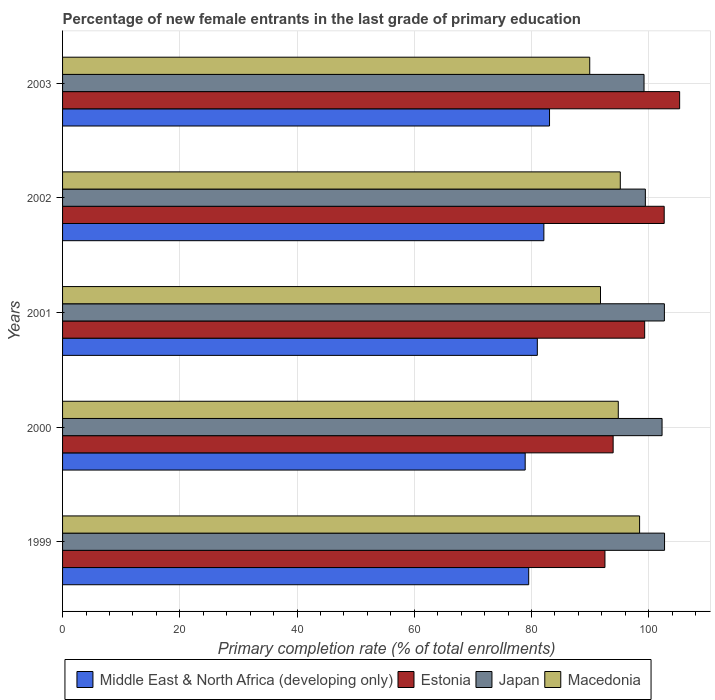How many groups of bars are there?
Your response must be concise. 5. How many bars are there on the 1st tick from the top?
Your answer should be very brief. 4. What is the label of the 1st group of bars from the top?
Provide a succinct answer. 2003. What is the percentage of new female entrants in Estonia in 2000?
Offer a very short reply. 93.93. Across all years, what is the maximum percentage of new female entrants in Macedonia?
Provide a short and direct response. 98.44. Across all years, what is the minimum percentage of new female entrants in Middle East & North Africa (developing only)?
Your answer should be compact. 78.92. What is the total percentage of new female entrants in Japan in the graph?
Offer a terse response. 506.26. What is the difference between the percentage of new female entrants in Japan in 2002 and that in 2003?
Keep it short and to the point. 0.23. What is the difference between the percentage of new female entrants in Macedonia in 2001 and the percentage of new female entrants in Estonia in 1999?
Provide a short and direct response. -0.76. What is the average percentage of new female entrants in Japan per year?
Provide a succinct answer. 101.25. In the year 1999, what is the difference between the percentage of new female entrants in Macedonia and percentage of new female entrants in Middle East & North Africa (developing only)?
Keep it short and to the point. 18.92. In how many years, is the percentage of new female entrants in Japan greater than 76 %?
Your response must be concise. 5. What is the ratio of the percentage of new female entrants in Japan in 2001 to that in 2002?
Your answer should be compact. 1.03. Is the difference between the percentage of new female entrants in Macedonia in 2000 and 2001 greater than the difference between the percentage of new female entrants in Middle East & North Africa (developing only) in 2000 and 2001?
Keep it short and to the point. Yes. What is the difference between the highest and the second highest percentage of new female entrants in Japan?
Your answer should be very brief. 0.03. What is the difference between the highest and the lowest percentage of new female entrants in Macedonia?
Ensure brevity in your answer.  8.51. In how many years, is the percentage of new female entrants in Japan greater than the average percentage of new female entrants in Japan taken over all years?
Provide a succinct answer. 3. Is the sum of the percentage of new female entrants in Estonia in 1999 and 2000 greater than the maximum percentage of new female entrants in Middle East & North Africa (developing only) across all years?
Keep it short and to the point. Yes. Is it the case that in every year, the sum of the percentage of new female entrants in Estonia and percentage of new female entrants in Middle East & North Africa (developing only) is greater than the sum of percentage of new female entrants in Japan and percentage of new female entrants in Macedonia?
Ensure brevity in your answer.  Yes. What does the 4th bar from the top in 2003 represents?
Give a very brief answer. Middle East & North Africa (developing only). What does the 4th bar from the bottom in 2003 represents?
Keep it short and to the point. Macedonia. Is it the case that in every year, the sum of the percentage of new female entrants in Macedonia and percentage of new female entrants in Middle East & North Africa (developing only) is greater than the percentage of new female entrants in Japan?
Your answer should be very brief. Yes. Are all the bars in the graph horizontal?
Your answer should be very brief. Yes. What is the difference between two consecutive major ticks on the X-axis?
Ensure brevity in your answer.  20. Where does the legend appear in the graph?
Your answer should be compact. Bottom center. What is the title of the graph?
Offer a terse response. Percentage of new female entrants in the last grade of primary education. Does "Vietnam" appear as one of the legend labels in the graph?
Offer a terse response. No. What is the label or title of the X-axis?
Ensure brevity in your answer.  Primary completion rate (% of total enrollments). What is the Primary completion rate (% of total enrollments) in Middle East & North Africa (developing only) in 1999?
Offer a very short reply. 79.52. What is the Primary completion rate (% of total enrollments) in Estonia in 1999?
Keep it short and to the point. 92.53. What is the Primary completion rate (% of total enrollments) in Japan in 1999?
Offer a terse response. 102.7. What is the Primary completion rate (% of total enrollments) of Macedonia in 1999?
Make the answer very short. 98.44. What is the Primary completion rate (% of total enrollments) of Middle East & North Africa (developing only) in 2000?
Make the answer very short. 78.92. What is the Primary completion rate (% of total enrollments) of Estonia in 2000?
Provide a succinct answer. 93.93. What is the Primary completion rate (% of total enrollments) of Japan in 2000?
Your answer should be compact. 102.27. What is the Primary completion rate (% of total enrollments) of Macedonia in 2000?
Provide a succinct answer. 94.8. What is the Primary completion rate (% of total enrollments) of Middle East & North Africa (developing only) in 2001?
Your response must be concise. 80.99. What is the Primary completion rate (% of total enrollments) in Estonia in 2001?
Provide a succinct answer. 99.31. What is the Primary completion rate (% of total enrollments) of Japan in 2001?
Your answer should be compact. 102.67. What is the Primary completion rate (% of total enrollments) in Macedonia in 2001?
Ensure brevity in your answer.  91.77. What is the Primary completion rate (% of total enrollments) of Middle East & North Africa (developing only) in 2002?
Provide a short and direct response. 82.11. What is the Primary completion rate (% of total enrollments) in Estonia in 2002?
Ensure brevity in your answer.  102.64. What is the Primary completion rate (% of total enrollments) in Japan in 2002?
Keep it short and to the point. 99.42. What is the Primary completion rate (% of total enrollments) of Macedonia in 2002?
Your response must be concise. 95.15. What is the Primary completion rate (% of total enrollments) in Middle East & North Africa (developing only) in 2003?
Your response must be concise. 83.07. What is the Primary completion rate (% of total enrollments) of Estonia in 2003?
Offer a terse response. 105.27. What is the Primary completion rate (% of total enrollments) in Japan in 2003?
Make the answer very short. 99.2. What is the Primary completion rate (% of total enrollments) in Macedonia in 2003?
Your response must be concise. 89.93. Across all years, what is the maximum Primary completion rate (% of total enrollments) of Middle East & North Africa (developing only)?
Give a very brief answer. 83.07. Across all years, what is the maximum Primary completion rate (% of total enrollments) in Estonia?
Provide a short and direct response. 105.27. Across all years, what is the maximum Primary completion rate (% of total enrollments) in Japan?
Keep it short and to the point. 102.7. Across all years, what is the maximum Primary completion rate (% of total enrollments) in Macedonia?
Keep it short and to the point. 98.44. Across all years, what is the minimum Primary completion rate (% of total enrollments) in Middle East & North Africa (developing only)?
Offer a very short reply. 78.92. Across all years, what is the minimum Primary completion rate (% of total enrollments) in Estonia?
Ensure brevity in your answer.  92.53. Across all years, what is the minimum Primary completion rate (% of total enrollments) in Japan?
Keep it short and to the point. 99.2. Across all years, what is the minimum Primary completion rate (% of total enrollments) in Macedonia?
Provide a short and direct response. 89.93. What is the total Primary completion rate (% of total enrollments) in Middle East & North Africa (developing only) in the graph?
Offer a very short reply. 404.62. What is the total Primary completion rate (% of total enrollments) in Estonia in the graph?
Provide a short and direct response. 493.67. What is the total Primary completion rate (% of total enrollments) in Japan in the graph?
Offer a very short reply. 506.26. What is the total Primary completion rate (% of total enrollments) of Macedonia in the graph?
Your answer should be very brief. 470.09. What is the difference between the Primary completion rate (% of total enrollments) in Middle East & North Africa (developing only) in 1999 and that in 2000?
Provide a short and direct response. 0.6. What is the difference between the Primary completion rate (% of total enrollments) of Estonia in 1999 and that in 2000?
Offer a terse response. -1.4. What is the difference between the Primary completion rate (% of total enrollments) in Japan in 1999 and that in 2000?
Give a very brief answer. 0.42. What is the difference between the Primary completion rate (% of total enrollments) in Macedonia in 1999 and that in 2000?
Your response must be concise. 3.64. What is the difference between the Primary completion rate (% of total enrollments) of Middle East & North Africa (developing only) in 1999 and that in 2001?
Your answer should be very brief. -1.47. What is the difference between the Primary completion rate (% of total enrollments) in Estonia in 1999 and that in 2001?
Offer a very short reply. -6.78. What is the difference between the Primary completion rate (% of total enrollments) of Japan in 1999 and that in 2001?
Your answer should be very brief. 0.03. What is the difference between the Primary completion rate (% of total enrollments) of Macedonia in 1999 and that in 2001?
Offer a very short reply. 6.67. What is the difference between the Primary completion rate (% of total enrollments) in Middle East & North Africa (developing only) in 1999 and that in 2002?
Your answer should be compact. -2.59. What is the difference between the Primary completion rate (% of total enrollments) in Estonia in 1999 and that in 2002?
Keep it short and to the point. -10.11. What is the difference between the Primary completion rate (% of total enrollments) of Japan in 1999 and that in 2002?
Make the answer very short. 3.27. What is the difference between the Primary completion rate (% of total enrollments) of Macedonia in 1999 and that in 2002?
Offer a terse response. 3.29. What is the difference between the Primary completion rate (% of total enrollments) in Middle East & North Africa (developing only) in 1999 and that in 2003?
Your answer should be very brief. -3.55. What is the difference between the Primary completion rate (% of total enrollments) of Estonia in 1999 and that in 2003?
Provide a succinct answer. -12.74. What is the difference between the Primary completion rate (% of total enrollments) in Japan in 1999 and that in 2003?
Ensure brevity in your answer.  3.5. What is the difference between the Primary completion rate (% of total enrollments) of Macedonia in 1999 and that in 2003?
Your answer should be compact. 8.51. What is the difference between the Primary completion rate (% of total enrollments) in Middle East & North Africa (developing only) in 2000 and that in 2001?
Your response must be concise. -2.07. What is the difference between the Primary completion rate (% of total enrollments) in Estonia in 2000 and that in 2001?
Give a very brief answer. -5.38. What is the difference between the Primary completion rate (% of total enrollments) of Japan in 2000 and that in 2001?
Give a very brief answer. -0.4. What is the difference between the Primary completion rate (% of total enrollments) in Macedonia in 2000 and that in 2001?
Your response must be concise. 3.03. What is the difference between the Primary completion rate (% of total enrollments) in Middle East & North Africa (developing only) in 2000 and that in 2002?
Provide a succinct answer. -3.19. What is the difference between the Primary completion rate (% of total enrollments) of Estonia in 2000 and that in 2002?
Your response must be concise. -8.71. What is the difference between the Primary completion rate (% of total enrollments) in Japan in 2000 and that in 2002?
Make the answer very short. 2.85. What is the difference between the Primary completion rate (% of total enrollments) of Macedonia in 2000 and that in 2002?
Your answer should be very brief. -0.34. What is the difference between the Primary completion rate (% of total enrollments) in Middle East & North Africa (developing only) in 2000 and that in 2003?
Your response must be concise. -4.15. What is the difference between the Primary completion rate (% of total enrollments) of Estonia in 2000 and that in 2003?
Provide a short and direct response. -11.34. What is the difference between the Primary completion rate (% of total enrollments) of Japan in 2000 and that in 2003?
Provide a succinct answer. 3.08. What is the difference between the Primary completion rate (% of total enrollments) of Macedonia in 2000 and that in 2003?
Offer a terse response. 4.87. What is the difference between the Primary completion rate (% of total enrollments) in Middle East & North Africa (developing only) in 2001 and that in 2002?
Your answer should be very brief. -1.12. What is the difference between the Primary completion rate (% of total enrollments) of Estonia in 2001 and that in 2002?
Keep it short and to the point. -3.33. What is the difference between the Primary completion rate (% of total enrollments) of Japan in 2001 and that in 2002?
Offer a terse response. 3.25. What is the difference between the Primary completion rate (% of total enrollments) of Macedonia in 2001 and that in 2002?
Your answer should be compact. -3.38. What is the difference between the Primary completion rate (% of total enrollments) in Middle East & North Africa (developing only) in 2001 and that in 2003?
Keep it short and to the point. -2.08. What is the difference between the Primary completion rate (% of total enrollments) in Estonia in 2001 and that in 2003?
Your response must be concise. -5.96. What is the difference between the Primary completion rate (% of total enrollments) of Japan in 2001 and that in 2003?
Make the answer very short. 3.47. What is the difference between the Primary completion rate (% of total enrollments) of Macedonia in 2001 and that in 2003?
Offer a very short reply. 1.83. What is the difference between the Primary completion rate (% of total enrollments) in Middle East & North Africa (developing only) in 2002 and that in 2003?
Offer a terse response. -0.96. What is the difference between the Primary completion rate (% of total enrollments) in Estonia in 2002 and that in 2003?
Provide a short and direct response. -2.63. What is the difference between the Primary completion rate (% of total enrollments) of Japan in 2002 and that in 2003?
Your response must be concise. 0.23. What is the difference between the Primary completion rate (% of total enrollments) in Macedonia in 2002 and that in 2003?
Offer a terse response. 5.21. What is the difference between the Primary completion rate (% of total enrollments) in Middle East & North Africa (developing only) in 1999 and the Primary completion rate (% of total enrollments) in Estonia in 2000?
Ensure brevity in your answer.  -14.4. What is the difference between the Primary completion rate (% of total enrollments) of Middle East & North Africa (developing only) in 1999 and the Primary completion rate (% of total enrollments) of Japan in 2000?
Ensure brevity in your answer.  -22.75. What is the difference between the Primary completion rate (% of total enrollments) of Middle East & North Africa (developing only) in 1999 and the Primary completion rate (% of total enrollments) of Macedonia in 2000?
Make the answer very short. -15.28. What is the difference between the Primary completion rate (% of total enrollments) in Estonia in 1999 and the Primary completion rate (% of total enrollments) in Japan in 2000?
Your answer should be compact. -9.74. What is the difference between the Primary completion rate (% of total enrollments) of Estonia in 1999 and the Primary completion rate (% of total enrollments) of Macedonia in 2000?
Offer a terse response. -2.27. What is the difference between the Primary completion rate (% of total enrollments) in Japan in 1999 and the Primary completion rate (% of total enrollments) in Macedonia in 2000?
Offer a terse response. 7.89. What is the difference between the Primary completion rate (% of total enrollments) in Middle East & North Africa (developing only) in 1999 and the Primary completion rate (% of total enrollments) in Estonia in 2001?
Provide a short and direct response. -19.78. What is the difference between the Primary completion rate (% of total enrollments) of Middle East & North Africa (developing only) in 1999 and the Primary completion rate (% of total enrollments) of Japan in 2001?
Make the answer very short. -23.15. What is the difference between the Primary completion rate (% of total enrollments) of Middle East & North Africa (developing only) in 1999 and the Primary completion rate (% of total enrollments) of Macedonia in 2001?
Give a very brief answer. -12.25. What is the difference between the Primary completion rate (% of total enrollments) in Estonia in 1999 and the Primary completion rate (% of total enrollments) in Japan in 2001?
Keep it short and to the point. -10.14. What is the difference between the Primary completion rate (% of total enrollments) of Estonia in 1999 and the Primary completion rate (% of total enrollments) of Macedonia in 2001?
Keep it short and to the point. 0.76. What is the difference between the Primary completion rate (% of total enrollments) of Japan in 1999 and the Primary completion rate (% of total enrollments) of Macedonia in 2001?
Offer a terse response. 10.93. What is the difference between the Primary completion rate (% of total enrollments) in Middle East & North Africa (developing only) in 1999 and the Primary completion rate (% of total enrollments) in Estonia in 2002?
Provide a short and direct response. -23.12. What is the difference between the Primary completion rate (% of total enrollments) in Middle East & North Africa (developing only) in 1999 and the Primary completion rate (% of total enrollments) in Japan in 2002?
Keep it short and to the point. -19.9. What is the difference between the Primary completion rate (% of total enrollments) in Middle East & North Africa (developing only) in 1999 and the Primary completion rate (% of total enrollments) in Macedonia in 2002?
Ensure brevity in your answer.  -15.63. What is the difference between the Primary completion rate (% of total enrollments) of Estonia in 1999 and the Primary completion rate (% of total enrollments) of Japan in 2002?
Ensure brevity in your answer.  -6.89. What is the difference between the Primary completion rate (% of total enrollments) in Estonia in 1999 and the Primary completion rate (% of total enrollments) in Macedonia in 2002?
Provide a short and direct response. -2.62. What is the difference between the Primary completion rate (% of total enrollments) of Japan in 1999 and the Primary completion rate (% of total enrollments) of Macedonia in 2002?
Provide a succinct answer. 7.55. What is the difference between the Primary completion rate (% of total enrollments) in Middle East & North Africa (developing only) in 1999 and the Primary completion rate (% of total enrollments) in Estonia in 2003?
Give a very brief answer. -25.75. What is the difference between the Primary completion rate (% of total enrollments) of Middle East & North Africa (developing only) in 1999 and the Primary completion rate (% of total enrollments) of Japan in 2003?
Ensure brevity in your answer.  -19.68. What is the difference between the Primary completion rate (% of total enrollments) in Middle East & North Africa (developing only) in 1999 and the Primary completion rate (% of total enrollments) in Macedonia in 2003?
Keep it short and to the point. -10.41. What is the difference between the Primary completion rate (% of total enrollments) in Estonia in 1999 and the Primary completion rate (% of total enrollments) in Japan in 2003?
Provide a succinct answer. -6.67. What is the difference between the Primary completion rate (% of total enrollments) in Estonia in 1999 and the Primary completion rate (% of total enrollments) in Macedonia in 2003?
Your answer should be very brief. 2.6. What is the difference between the Primary completion rate (% of total enrollments) in Japan in 1999 and the Primary completion rate (% of total enrollments) in Macedonia in 2003?
Offer a very short reply. 12.76. What is the difference between the Primary completion rate (% of total enrollments) of Middle East & North Africa (developing only) in 2000 and the Primary completion rate (% of total enrollments) of Estonia in 2001?
Make the answer very short. -20.38. What is the difference between the Primary completion rate (% of total enrollments) of Middle East & North Africa (developing only) in 2000 and the Primary completion rate (% of total enrollments) of Japan in 2001?
Your answer should be compact. -23.75. What is the difference between the Primary completion rate (% of total enrollments) of Middle East & North Africa (developing only) in 2000 and the Primary completion rate (% of total enrollments) of Macedonia in 2001?
Provide a short and direct response. -12.85. What is the difference between the Primary completion rate (% of total enrollments) in Estonia in 2000 and the Primary completion rate (% of total enrollments) in Japan in 2001?
Offer a terse response. -8.74. What is the difference between the Primary completion rate (% of total enrollments) of Estonia in 2000 and the Primary completion rate (% of total enrollments) of Macedonia in 2001?
Your response must be concise. 2.16. What is the difference between the Primary completion rate (% of total enrollments) of Japan in 2000 and the Primary completion rate (% of total enrollments) of Macedonia in 2001?
Your response must be concise. 10.5. What is the difference between the Primary completion rate (% of total enrollments) of Middle East & North Africa (developing only) in 2000 and the Primary completion rate (% of total enrollments) of Estonia in 2002?
Your response must be concise. -23.72. What is the difference between the Primary completion rate (% of total enrollments) of Middle East & North Africa (developing only) in 2000 and the Primary completion rate (% of total enrollments) of Japan in 2002?
Offer a very short reply. -20.5. What is the difference between the Primary completion rate (% of total enrollments) in Middle East & North Africa (developing only) in 2000 and the Primary completion rate (% of total enrollments) in Macedonia in 2002?
Provide a short and direct response. -16.23. What is the difference between the Primary completion rate (% of total enrollments) in Estonia in 2000 and the Primary completion rate (% of total enrollments) in Japan in 2002?
Your answer should be very brief. -5.5. What is the difference between the Primary completion rate (% of total enrollments) of Estonia in 2000 and the Primary completion rate (% of total enrollments) of Macedonia in 2002?
Give a very brief answer. -1.22. What is the difference between the Primary completion rate (% of total enrollments) in Japan in 2000 and the Primary completion rate (% of total enrollments) in Macedonia in 2002?
Keep it short and to the point. 7.13. What is the difference between the Primary completion rate (% of total enrollments) in Middle East & North Africa (developing only) in 2000 and the Primary completion rate (% of total enrollments) in Estonia in 2003?
Your answer should be compact. -26.35. What is the difference between the Primary completion rate (% of total enrollments) in Middle East & North Africa (developing only) in 2000 and the Primary completion rate (% of total enrollments) in Japan in 2003?
Provide a short and direct response. -20.28. What is the difference between the Primary completion rate (% of total enrollments) of Middle East & North Africa (developing only) in 2000 and the Primary completion rate (% of total enrollments) of Macedonia in 2003?
Your answer should be compact. -11.01. What is the difference between the Primary completion rate (% of total enrollments) in Estonia in 2000 and the Primary completion rate (% of total enrollments) in Japan in 2003?
Provide a succinct answer. -5.27. What is the difference between the Primary completion rate (% of total enrollments) in Estonia in 2000 and the Primary completion rate (% of total enrollments) in Macedonia in 2003?
Your response must be concise. 3.99. What is the difference between the Primary completion rate (% of total enrollments) in Japan in 2000 and the Primary completion rate (% of total enrollments) in Macedonia in 2003?
Make the answer very short. 12.34. What is the difference between the Primary completion rate (% of total enrollments) in Middle East & North Africa (developing only) in 2001 and the Primary completion rate (% of total enrollments) in Estonia in 2002?
Give a very brief answer. -21.65. What is the difference between the Primary completion rate (% of total enrollments) in Middle East & North Africa (developing only) in 2001 and the Primary completion rate (% of total enrollments) in Japan in 2002?
Give a very brief answer. -18.43. What is the difference between the Primary completion rate (% of total enrollments) in Middle East & North Africa (developing only) in 2001 and the Primary completion rate (% of total enrollments) in Macedonia in 2002?
Ensure brevity in your answer.  -14.15. What is the difference between the Primary completion rate (% of total enrollments) of Estonia in 2001 and the Primary completion rate (% of total enrollments) of Japan in 2002?
Your answer should be very brief. -0.12. What is the difference between the Primary completion rate (% of total enrollments) in Estonia in 2001 and the Primary completion rate (% of total enrollments) in Macedonia in 2002?
Your answer should be very brief. 4.16. What is the difference between the Primary completion rate (% of total enrollments) in Japan in 2001 and the Primary completion rate (% of total enrollments) in Macedonia in 2002?
Offer a terse response. 7.52. What is the difference between the Primary completion rate (% of total enrollments) in Middle East & North Africa (developing only) in 2001 and the Primary completion rate (% of total enrollments) in Estonia in 2003?
Offer a terse response. -24.28. What is the difference between the Primary completion rate (% of total enrollments) of Middle East & North Africa (developing only) in 2001 and the Primary completion rate (% of total enrollments) of Japan in 2003?
Your answer should be very brief. -18.2. What is the difference between the Primary completion rate (% of total enrollments) of Middle East & North Africa (developing only) in 2001 and the Primary completion rate (% of total enrollments) of Macedonia in 2003?
Your answer should be compact. -8.94. What is the difference between the Primary completion rate (% of total enrollments) of Estonia in 2001 and the Primary completion rate (% of total enrollments) of Japan in 2003?
Provide a short and direct response. 0.11. What is the difference between the Primary completion rate (% of total enrollments) in Estonia in 2001 and the Primary completion rate (% of total enrollments) in Macedonia in 2003?
Keep it short and to the point. 9.37. What is the difference between the Primary completion rate (% of total enrollments) of Japan in 2001 and the Primary completion rate (% of total enrollments) of Macedonia in 2003?
Provide a succinct answer. 12.74. What is the difference between the Primary completion rate (% of total enrollments) of Middle East & North Africa (developing only) in 2002 and the Primary completion rate (% of total enrollments) of Estonia in 2003?
Ensure brevity in your answer.  -23.16. What is the difference between the Primary completion rate (% of total enrollments) of Middle East & North Africa (developing only) in 2002 and the Primary completion rate (% of total enrollments) of Japan in 2003?
Your response must be concise. -17.09. What is the difference between the Primary completion rate (% of total enrollments) in Middle East & North Africa (developing only) in 2002 and the Primary completion rate (% of total enrollments) in Macedonia in 2003?
Offer a terse response. -7.82. What is the difference between the Primary completion rate (% of total enrollments) of Estonia in 2002 and the Primary completion rate (% of total enrollments) of Japan in 2003?
Your answer should be very brief. 3.44. What is the difference between the Primary completion rate (% of total enrollments) of Estonia in 2002 and the Primary completion rate (% of total enrollments) of Macedonia in 2003?
Offer a very short reply. 12.7. What is the difference between the Primary completion rate (% of total enrollments) in Japan in 2002 and the Primary completion rate (% of total enrollments) in Macedonia in 2003?
Keep it short and to the point. 9.49. What is the average Primary completion rate (% of total enrollments) of Middle East & North Africa (developing only) per year?
Keep it short and to the point. 80.92. What is the average Primary completion rate (% of total enrollments) of Estonia per year?
Offer a very short reply. 98.73. What is the average Primary completion rate (% of total enrollments) of Japan per year?
Keep it short and to the point. 101.25. What is the average Primary completion rate (% of total enrollments) in Macedonia per year?
Provide a succinct answer. 94.02. In the year 1999, what is the difference between the Primary completion rate (% of total enrollments) in Middle East & North Africa (developing only) and Primary completion rate (% of total enrollments) in Estonia?
Provide a succinct answer. -13.01. In the year 1999, what is the difference between the Primary completion rate (% of total enrollments) of Middle East & North Africa (developing only) and Primary completion rate (% of total enrollments) of Japan?
Make the answer very short. -23.17. In the year 1999, what is the difference between the Primary completion rate (% of total enrollments) in Middle East & North Africa (developing only) and Primary completion rate (% of total enrollments) in Macedonia?
Make the answer very short. -18.92. In the year 1999, what is the difference between the Primary completion rate (% of total enrollments) in Estonia and Primary completion rate (% of total enrollments) in Japan?
Keep it short and to the point. -10.17. In the year 1999, what is the difference between the Primary completion rate (% of total enrollments) of Estonia and Primary completion rate (% of total enrollments) of Macedonia?
Your answer should be very brief. -5.91. In the year 1999, what is the difference between the Primary completion rate (% of total enrollments) of Japan and Primary completion rate (% of total enrollments) of Macedonia?
Provide a succinct answer. 4.26. In the year 2000, what is the difference between the Primary completion rate (% of total enrollments) of Middle East & North Africa (developing only) and Primary completion rate (% of total enrollments) of Estonia?
Make the answer very short. -15.01. In the year 2000, what is the difference between the Primary completion rate (% of total enrollments) of Middle East & North Africa (developing only) and Primary completion rate (% of total enrollments) of Japan?
Provide a short and direct response. -23.35. In the year 2000, what is the difference between the Primary completion rate (% of total enrollments) in Middle East & North Africa (developing only) and Primary completion rate (% of total enrollments) in Macedonia?
Your answer should be compact. -15.88. In the year 2000, what is the difference between the Primary completion rate (% of total enrollments) of Estonia and Primary completion rate (% of total enrollments) of Japan?
Your answer should be very brief. -8.35. In the year 2000, what is the difference between the Primary completion rate (% of total enrollments) of Estonia and Primary completion rate (% of total enrollments) of Macedonia?
Your answer should be compact. -0.88. In the year 2000, what is the difference between the Primary completion rate (% of total enrollments) of Japan and Primary completion rate (% of total enrollments) of Macedonia?
Give a very brief answer. 7.47. In the year 2001, what is the difference between the Primary completion rate (% of total enrollments) of Middle East & North Africa (developing only) and Primary completion rate (% of total enrollments) of Estonia?
Give a very brief answer. -18.31. In the year 2001, what is the difference between the Primary completion rate (% of total enrollments) in Middle East & North Africa (developing only) and Primary completion rate (% of total enrollments) in Japan?
Make the answer very short. -21.68. In the year 2001, what is the difference between the Primary completion rate (% of total enrollments) of Middle East & North Africa (developing only) and Primary completion rate (% of total enrollments) of Macedonia?
Keep it short and to the point. -10.78. In the year 2001, what is the difference between the Primary completion rate (% of total enrollments) in Estonia and Primary completion rate (% of total enrollments) in Japan?
Offer a terse response. -3.36. In the year 2001, what is the difference between the Primary completion rate (% of total enrollments) of Estonia and Primary completion rate (% of total enrollments) of Macedonia?
Offer a terse response. 7.54. In the year 2001, what is the difference between the Primary completion rate (% of total enrollments) of Japan and Primary completion rate (% of total enrollments) of Macedonia?
Offer a very short reply. 10.9. In the year 2002, what is the difference between the Primary completion rate (% of total enrollments) of Middle East & North Africa (developing only) and Primary completion rate (% of total enrollments) of Estonia?
Your answer should be compact. -20.53. In the year 2002, what is the difference between the Primary completion rate (% of total enrollments) in Middle East & North Africa (developing only) and Primary completion rate (% of total enrollments) in Japan?
Keep it short and to the point. -17.31. In the year 2002, what is the difference between the Primary completion rate (% of total enrollments) in Middle East & North Africa (developing only) and Primary completion rate (% of total enrollments) in Macedonia?
Provide a succinct answer. -13.04. In the year 2002, what is the difference between the Primary completion rate (% of total enrollments) of Estonia and Primary completion rate (% of total enrollments) of Japan?
Provide a short and direct response. 3.21. In the year 2002, what is the difference between the Primary completion rate (% of total enrollments) in Estonia and Primary completion rate (% of total enrollments) in Macedonia?
Offer a terse response. 7.49. In the year 2002, what is the difference between the Primary completion rate (% of total enrollments) in Japan and Primary completion rate (% of total enrollments) in Macedonia?
Your response must be concise. 4.28. In the year 2003, what is the difference between the Primary completion rate (% of total enrollments) of Middle East & North Africa (developing only) and Primary completion rate (% of total enrollments) of Estonia?
Your response must be concise. -22.2. In the year 2003, what is the difference between the Primary completion rate (% of total enrollments) in Middle East & North Africa (developing only) and Primary completion rate (% of total enrollments) in Japan?
Offer a terse response. -16.12. In the year 2003, what is the difference between the Primary completion rate (% of total enrollments) of Middle East & North Africa (developing only) and Primary completion rate (% of total enrollments) of Macedonia?
Offer a terse response. -6.86. In the year 2003, what is the difference between the Primary completion rate (% of total enrollments) of Estonia and Primary completion rate (% of total enrollments) of Japan?
Offer a terse response. 6.07. In the year 2003, what is the difference between the Primary completion rate (% of total enrollments) in Estonia and Primary completion rate (% of total enrollments) in Macedonia?
Offer a terse response. 15.34. In the year 2003, what is the difference between the Primary completion rate (% of total enrollments) of Japan and Primary completion rate (% of total enrollments) of Macedonia?
Your answer should be compact. 9.26. What is the ratio of the Primary completion rate (% of total enrollments) in Middle East & North Africa (developing only) in 1999 to that in 2000?
Make the answer very short. 1.01. What is the ratio of the Primary completion rate (% of total enrollments) in Estonia in 1999 to that in 2000?
Your answer should be compact. 0.99. What is the ratio of the Primary completion rate (% of total enrollments) of Japan in 1999 to that in 2000?
Give a very brief answer. 1. What is the ratio of the Primary completion rate (% of total enrollments) in Macedonia in 1999 to that in 2000?
Give a very brief answer. 1.04. What is the ratio of the Primary completion rate (% of total enrollments) of Middle East & North Africa (developing only) in 1999 to that in 2001?
Your answer should be very brief. 0.98. What is the ratio of the Primary completion rate (% of total enrollments) of Estonia in 1999 to that in 2001?
Make the answer very short. 0.93. What is the ratio of the Primary completion rate (% of total enrollments) of Japan in 1999 to that in 2001?
Provide a succinct answer. 1. What is the ratio of the Primary completion rate (% of total enrollments) of Macedonia in 1999 to that in 2001?
Provide a succinct answer. 1.07. What is the ratio of the Primary completion rate (% of total enrollments) of Middle East & North Africa (developing only) in 1999 to that in 2002?
Keep it short and to the point. 0.97. What is the ratio of the Primary completion rate (% of total enrollments) in Estonia in 1999 to that in 2002?
Your response must be concise. 0.9. What is the ratio of the Primary completion rate (% of total enrollments) of Japan in 1999 to that in 2002?
Ensure brevity in your answer.  1.03. What is the ratio of the Primary completion rate (% of total enrollments) in Macedonia in 1999 to that in 2002?
Your response must be concise. 1.03. What is the ratio of the Primary completion rate (% of total enrollments) of Middle East & North Africa (developing only) in 1999 to that in 2003?
Give a very brief answer. 0.96. What is the ratio of the Primary completion rate (% of total enrollments) in Estonia in 1999 to that in 2003?
Ensure brevity in your answer.  0.88. What is the ratio of the Primary completion rate (% of total enrollments) of Japan in 1999 to that in 2003?
Make the answer very short. 1.04. What is the ratio of the Primary completion rate (% of total enrollments) in Macedonia in 1999 to that in 2003?
Your answer should be compact. 1.09. What is the ratio of the Primary completion rate (% of total enrollments) in Middle East & North Africa (developing only) in 2000 to that in 2001?
Ensure brevity in your answer.  0.97. What is the ratio of the Primary completion rate (% of total enrollments) of Estonia in 2000 to that in 2001?
Provide a succinct answer. 0.95. What is the ratio of the Primary completion rate (% of total enrollments) of Japan in 2000 to that in 2001?
Make the answer very short. 1. What is the ratio of the Primary completion rate (% of total enrollments) in Macedonia in 2000 to that in 2001?
Offer a terse response. 1.03. What is the ratio of the Primary completion rate (% of total enrollments) in Middle East & North Africa (developing only) in 2000 to that in 2002?
Provide a succinct answer. 0.96. What is the ratio of the Primary completion rate (% of total enrollments) of Estonia in 2000 to that in 2002?
Your answer should be compact. 0.92. What is the ratio of the Primary completion rate (% of total enrollments) in Japan in 2000 to that in 2002?
Ensure brevity in your answer.  1.03. What is the ratio of the Primary completion rate (% of total enrollments) of Estonia in 2000 to that in 2003?
Keep it short and to the point. 0.89. What is the ratio of the Primary completion rate (% of total enrollments) in Japan in 2000 to that in 2003?
Provide a succinct answer. 1.03. What is the ratio of the Primary completion rate (% of total enrollments) in Macedonia in 2000 to that in 2003?
Offer a terse response. 1.05. What is the ratio of the Primary completion rate (% of total enrollments) of Middle East & North Africa (developing only) in 2001 to that in 2002?
Your response must be concise. 0.99. What is the ratio of the Primary completion rate (% of total enrollments) in Estonia in 2001 to that in 2002?
Provide a succinct answer. 0.97. What is the ratio of the Primary completion rate (% of total enrollments) in Japan in 2001 to that in 2002?
Your answer should be very brief. 1.03. What is the ratio of the Primary completion rate (% of total enrollments) in Macedonia in 2001 to that in 2002?
Give a very brief answer. 0.96. What is the ratio of the Primary completion rate (% of total enrollments) of Middle East & North Africa (developing only) in 2001 to that in 2003?
Offer a terse response. 0.97. What is the ratio of the Primary completion rate (% of total enrollments) of Estonia in 2001 to that in 2003?
Your answer should be very brief. 0.94. What is the ratio of the Primary completion rate (% of total enrollments) of Japan in 2001 to that in 2003?
Ensure brevity in your answer.  1.03. What is the ratio of the Primary completion rate (% of total enrollments) of Macedonia in 2001 to that in 2003?
Your answer should be compact. 1.02. What is the ratio of the Primary completion rate (% of total enrollments) of Middle East & North Africa (developing only) in 2002 to that in 2003?
Your answer should be compact. 0.99. What is the ratio of the Primary completion rate (% of total enrollments) of Estonia in 2002 to that in 2003?
Provide a short and direct response. 0.97. What is the ratio of the Primary completion rate (% of total enrollments) in Japan in 2002 to that in 2003?
Provide a succinct answer. 1. What is the ratio of the Primary completion rate (% of total enrollments) in Macedonia in 2002 to that in 2003?
Give a very brief answer. 1.06. What is the difference between the highest and the second highest Primary completion rate (% of total enrollments) in Middle East & North Africa (developing only)?
Offer a very short reply. 0.96. What is the difference between the highest and the second highest Primary completion rate (% of total enrollments) of Estonia?
Give a very brief answer. 2.63. What is the difference between the highest and the second highest Primary completion rate (% of total enrollments) of Japan?
Make the answer very short. 0.03. What is the difference between the highest and the second highest Primary completion rate (% of total enrollments) of Macedonia?
Make the answer very short. 3.29. What is the difference between the highest and the lowest Primary completion rate (% of total enrollments) in Middle East & North Africa (developing only)?
Give a very brief answer. 4.15. What is the difference between the highest and the lowest Primary completion rate (% of total enrollments) of Estonia?
Provide a succinct answer. 12.74. What is the difference between the highest and the lowest Primary completion rate (% of total enrollments) in Japan?
Make the answer very short. 3.5. What is the difference between the highest and the lowest Primary completion rate (% of total enrollments) in Macedonia?
Offer a terse response. 8.51. 